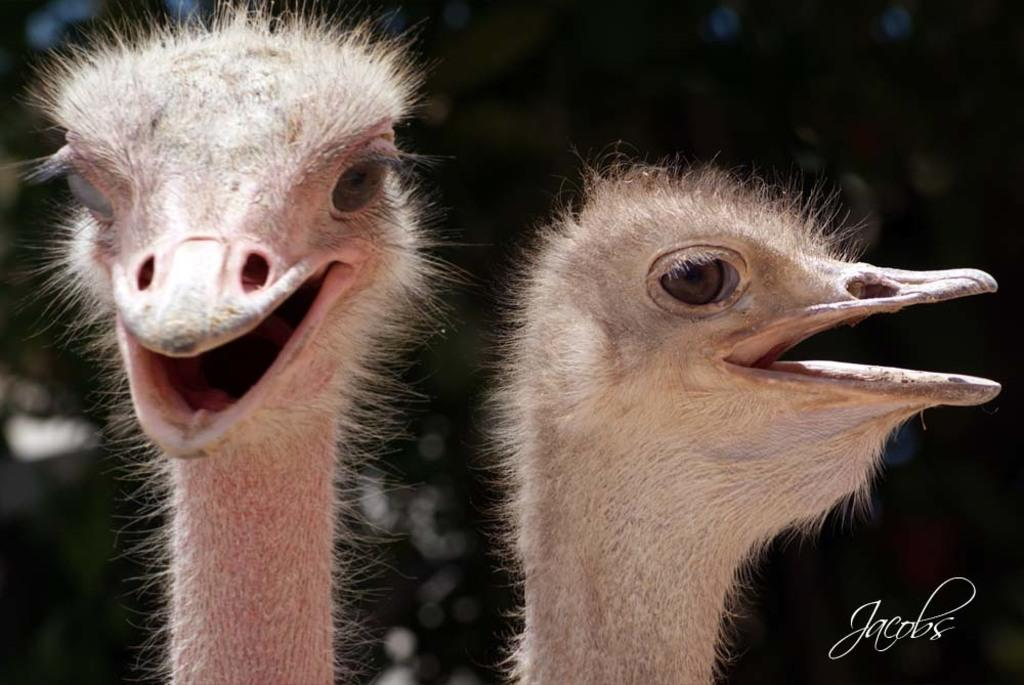What animals are present in the image? There are two ostriches in the image. Can you describe the background of the image? The background of the image is blurry. Is there any additional information or marking in the image? Yes, there is a watermark in the bottom right corner of the image. What arithmetic problem can be solved using the ostriches in the image? There is no arithmetic problem present in the image, as it features two ostriches and a blurry background. Can you describe the alley where the ostriches are located in the image? There is no alley present in the image; it is an open area with a blurry background. 